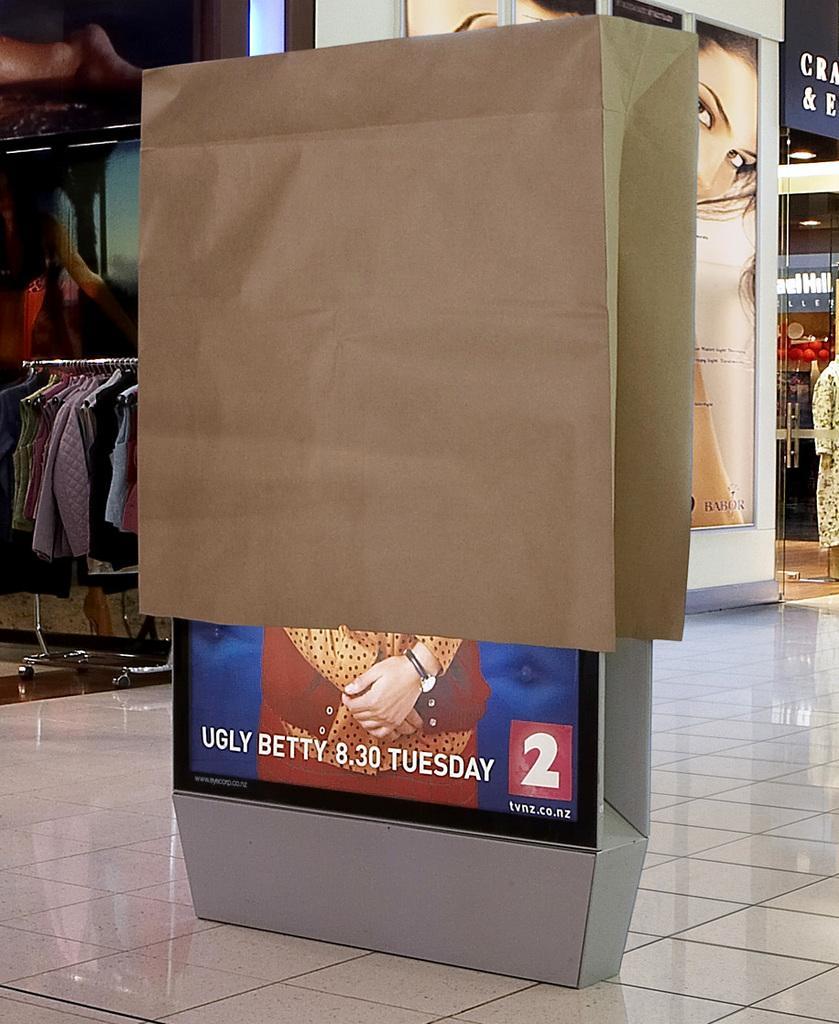In one or two sentences, can you explain what this image depicts? In the picture I can see an LED board is covered with paper bag. In the background I can see clothes, boards which has photos of women and some other objects. 